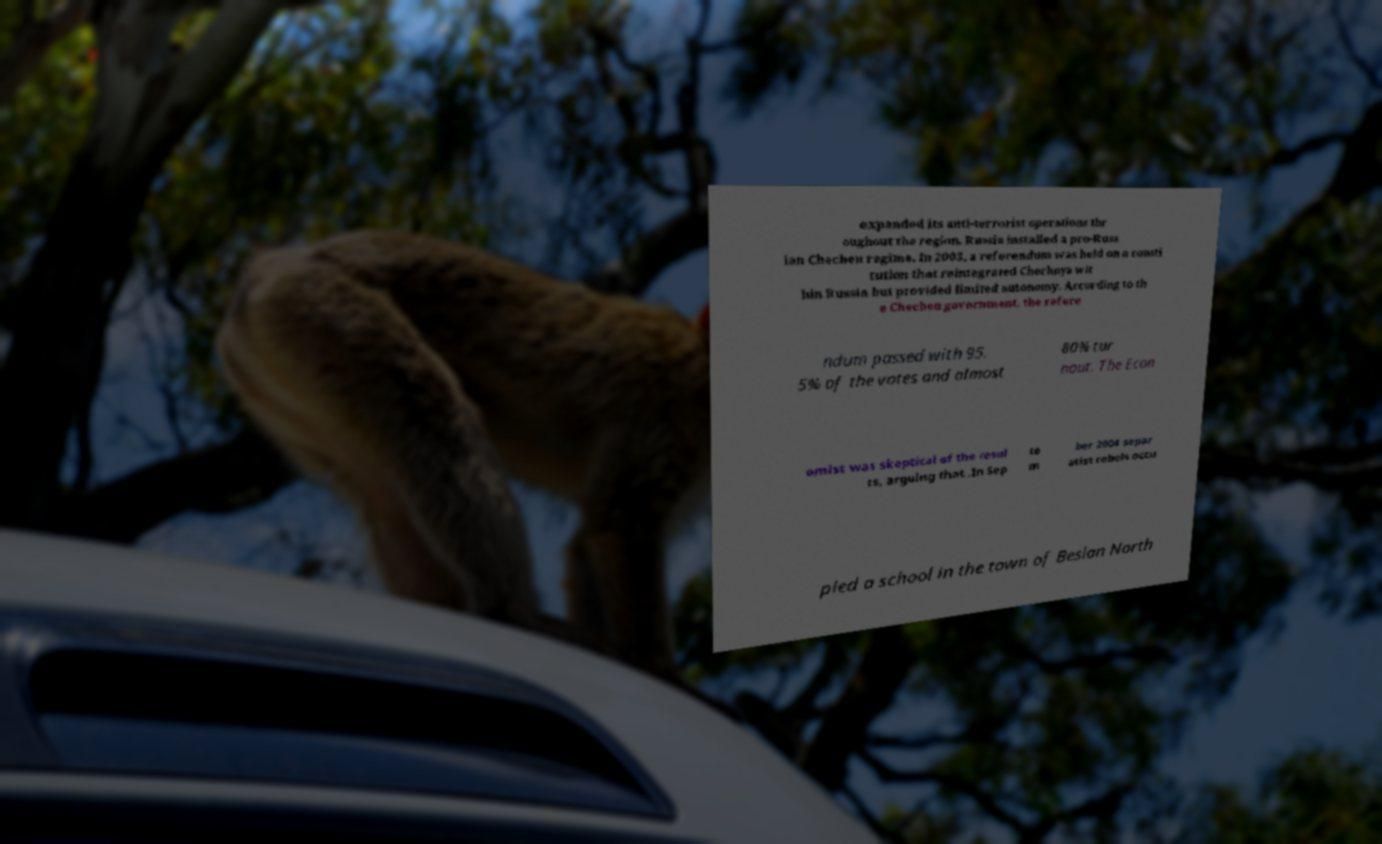There's text embedded in this image that I need extracted. Can you transcribe it verbatim? expanded its anti-terrorist operations thr oughout the region. Russia installed a pro-Russ ian Chechen regime. In 2003, a referendum was held on a consti tution that reintegrated Chechnya wit hin Russia but provided limited autonomy. According to th e Chechen government, the refere ndum passed with 95. 5% of the votes and almost 80% tur nout. The Econ omist was skeptical of the resul ts, arguing that .In Sep te m ber 2004 separ atist rebels occu pied a school in the town of Beslan North 